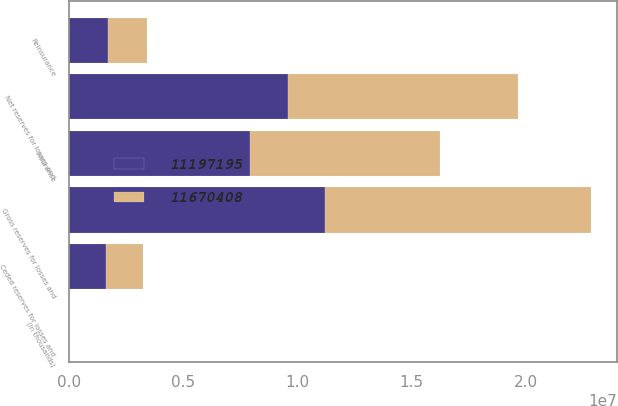Convert chart to OTSL. <chart><loc_0><loc_0><loc_500><loc_500><stacked_bar_chart><ecel><fcel>(In thousands)<fcel>Insurance<fcel>Reinsurance<fcel>Net reserves for losses and<fcel>Ceded reserves for losses and<fcel>Gross reserves for losses and<nl><fcel>1.16704e+07<fcel>2017<fcel>8.34162e+06<fcel>1.71529e+06<fcel>1.00569e+07<fcel>1.61349e+06<fcel>1.16704e+07<nl><fcel>1.11972e+07<fcel>2016<fcel>7.91307e+06<fcel>1.67719e+06<fcel>9.59026e+06<fcel>1.60693e+06<fcel>1.11972e+07<nl></chart> 